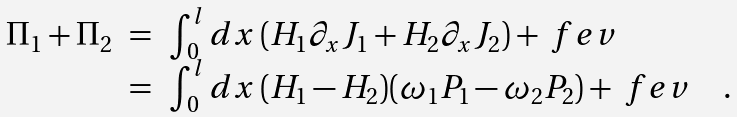<formula> <loc_0><loc_0><loc_500><loc_500>\begin{array} { l l l } \Pi _ { 1 } + \Pi _ { 2 } & = & \int _ { 0 } ^ { l } d x \, ( H _ { 1 } \partial _ { x } J _ { 1 } + H _ { 2 } \partial _ { x } J _ { 2 } ) + \ f e v \\ & = & \int _ { 0 } ^ { l } d x \, ( H _ { 1 } - H _ { 2 } ) ( \omega _ { 1 } P _ { 1 } - \omega _ { 2 } P _ { 2 } ) + \ f e v \quad . \end{array}</formula> 